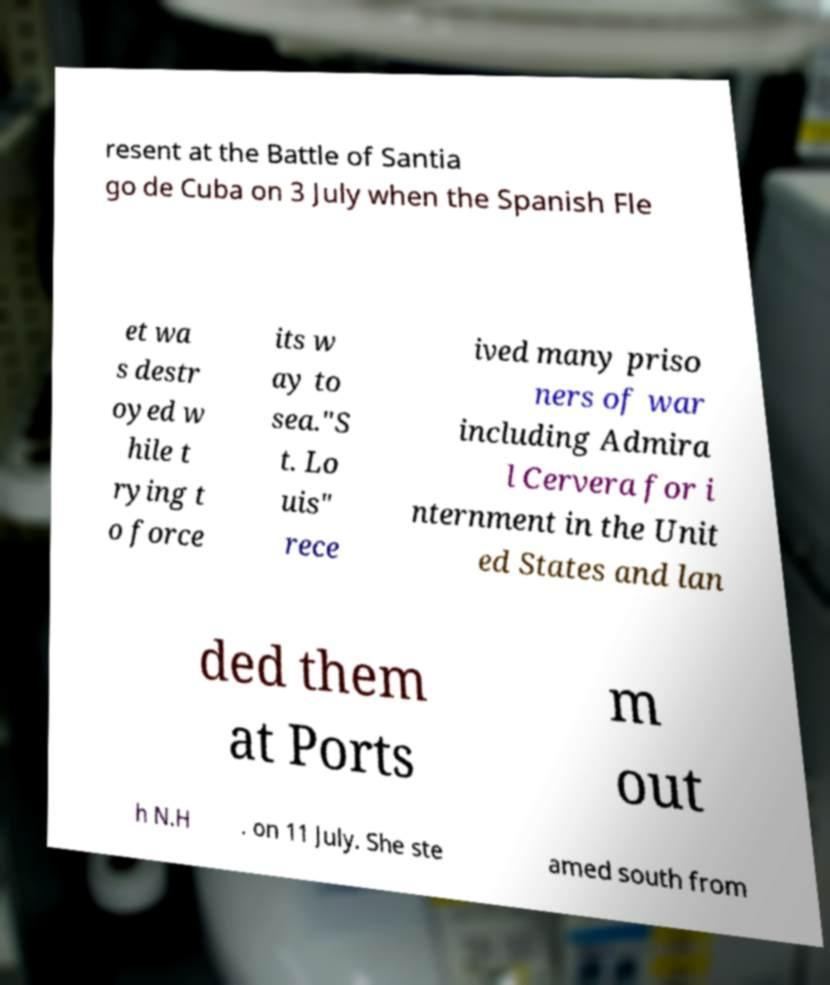What messages or text are displayed in this image? I need them in a readable, typed format. resent at the Battle of Santia go de Cuba on 3 July when the Spanish Fle et wa s destr oyed w hile t rying t o force its w ay to sea."S t. Lo uis" rece ived many priso ners of war including Admira l Cervera for i nternment in the Unit ed States and lan ded them at Ports m out h N.H . on 11 July. She ste amed south from 